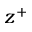<formula> <loc_0><loc_0><loc_500><loc_500>z ^ { + }</formula> 